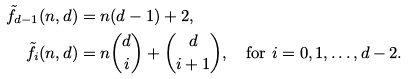<formula> <loc_0><loc_0><loc_500><loc_500>\tilde { f } _ { d - 1 } ( n , d ) & = n ( d - 1 ) + 2 , \\ \tilde { f } _ { i } ( n , d ) & = n { \binom { d } { i } } + \binom { d } { i + 1 } , \quad \text {for } i = 0 , 1 , \dots , d - 2 .</formula> 